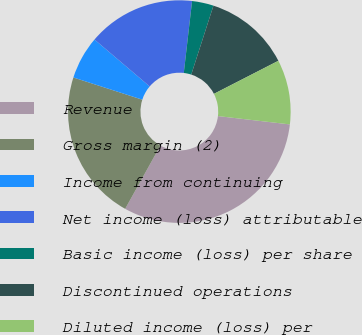<chart> <loc_0><loc_0><loc_500><loc_500><pie_chart><fcel>Revenue<fcel>Gross margin (2)<fcel>Income from continuing<fcel>Net income (loss) attributable<fcel>Basic income (loss) per share<fcel>Discontinued operations<fcel>Diluted income (loss) per<nl><fcel>31.25%<fcel>21.87%<fcel>6.25%<fcel>15.62%<fcel>3.13%<fcel>12.5%<fcel>9.38%<nl></chart> 